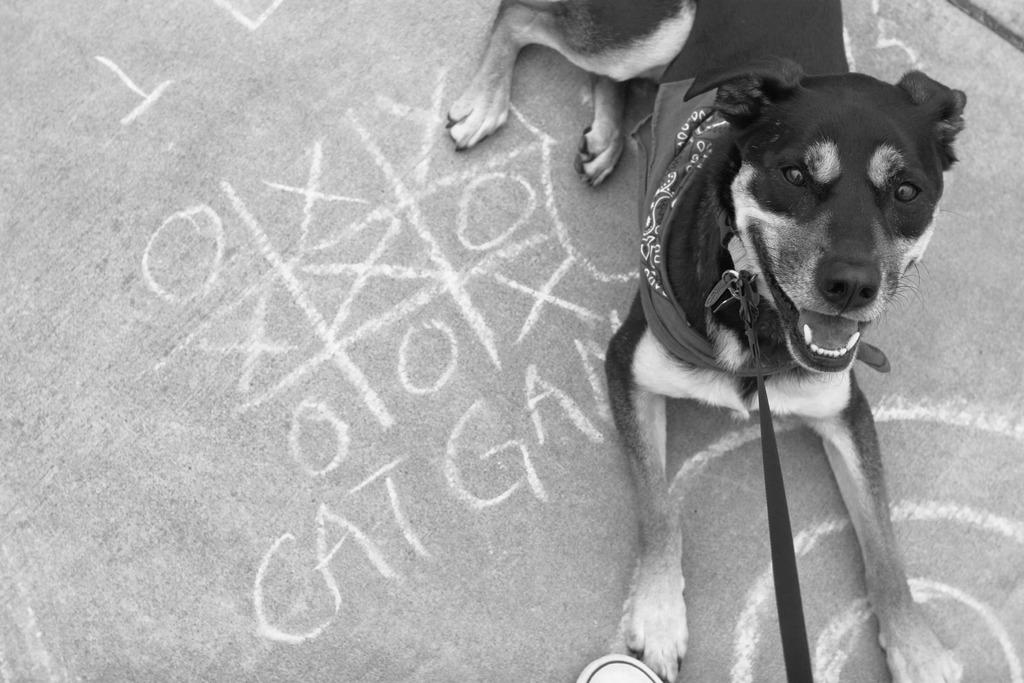What type of animal is in the image? There is a dog in the image. What is the dog doing in the image? The dog is sitting on the floor. Is there anything around the dog's neck? Yes, there is a belt around the dog's neck. What else can be seen on the floor in the image? There is some text on the floor. How is the image presented in terms of color? The image is black and white. What type of yoke is the dog pulling in the image? There is no yoke present in the image; the dog is sitting on the floor with a belt around its neck. What is the dog's income in the image? The image does not provide information about the dog's income, as it is not a living being with an income. 